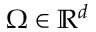Convert formula to latex. <formula><loc_0><loc_0><loc_500><loc_500>\Omega \in \mathbb { R } ^ { d }</formula> 